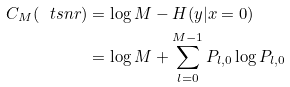Convert formula to latex. <formula><loc_0><loc_0><loc_500><loc_500>C _ { M } ( \ t s n r ) & = \log M - H ( y | x = 0 ) \\ & = \log M + \sum _ { l = 0 } ^ { M - 1 } P _ { l , 0 } \log P _ { l , 0 }</formula> 